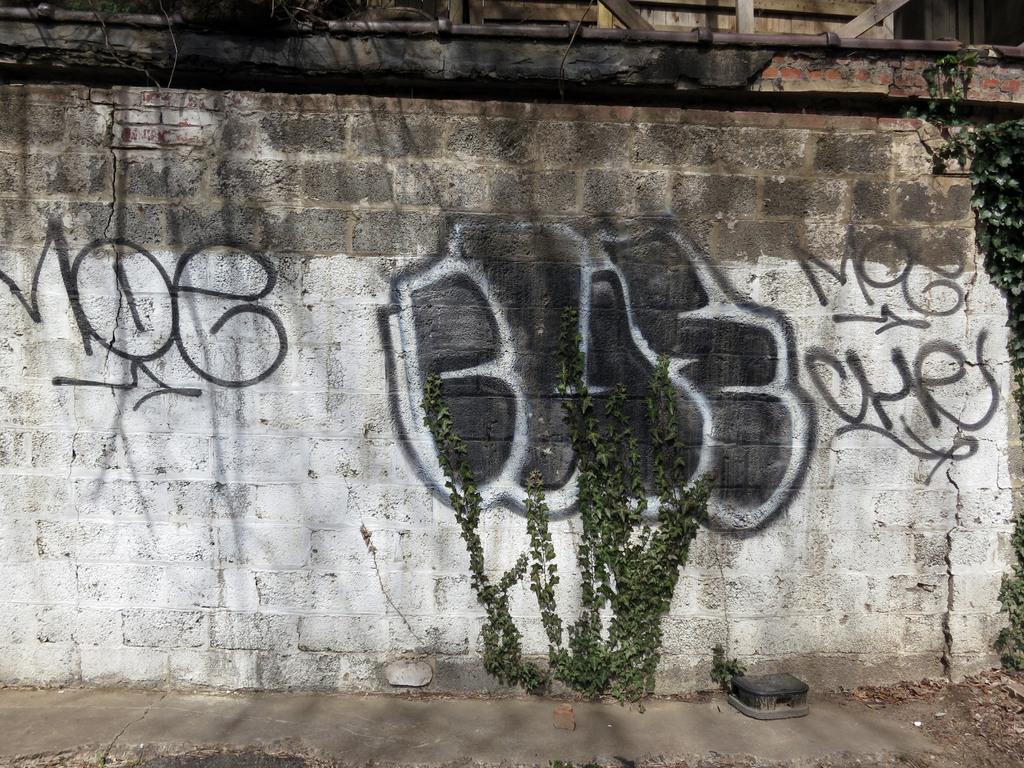Please provide a concise description of this image. Here in this picture we can see a wall, on which we can see something written on drawn over there and we can also see some plants present over there. 